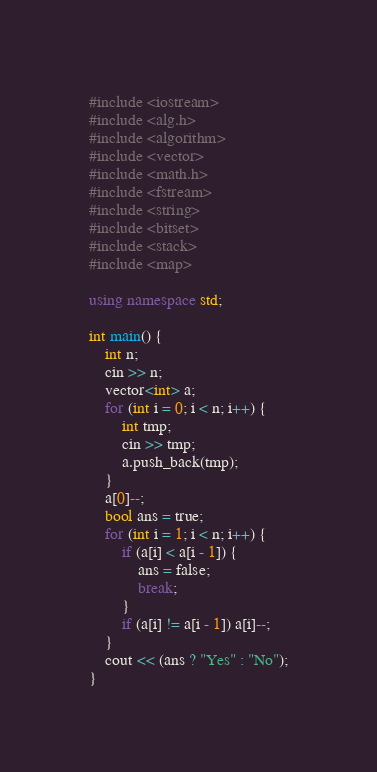<code> <loc_0><loc_0><loc_500><loc_500><_C++_>#include <iostream>
#include <alg.h>
#include <algorithm>
#include <vector>
#include <math.h>
#include <fstream>
#include <string>
#include <bitset>
#include <stack>
#include <map>

using namespace std;

int main() {
	int n;
	cin >> n;
	vector<int> a;
	for (int i = 0; i < n; i++) {
		int tmp;
		cin >> tmp;
		a.push_back(tmp);
	}
	a[0]--;
	bool ans = true;
	for (int i = 1; i < n; i++) {
		if (a[i] < a[i - 1]) {
			ans = false;
			break;
		}
		if (a[i] != a[i - 1]) a[i]--;
	}
	cout << (ans ? "Yes" : "No");
}</code> 